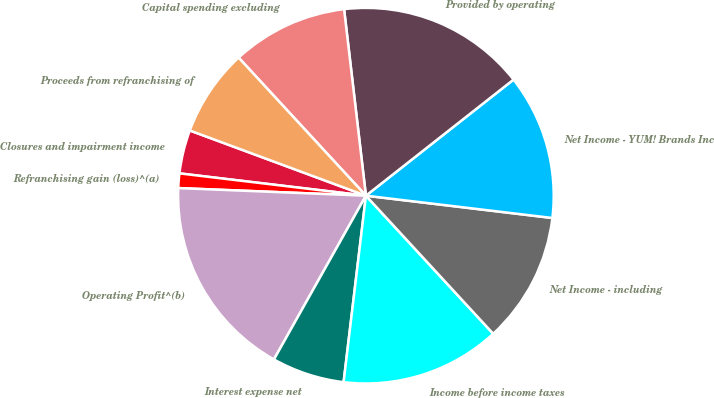Convert chart to OTSL. <chart><loc_0><loc_0><loc_500><loc_500><pie_chart><fcel>Closures and impairment income<fcel>Refranchising gain (loss)^(a)<fcel>Operating Profit^(b)<fcel>Interest expense net<fcel>Income before income taxes<fcel>Net Income - including<fcel>Net Income - YUM! Brands Inc<fcel>Provided by operating<fcel>Capital spending excluding<fcel>Proceeds from refranchising of<nl><fcel>3.75%<fcel>1.25%<fcel>17.5%<fcel>6.25%<fcel>13.75%<fcel>11.25%<fcel>12.5%<fcel>16.25%<fcel>10.0%<fcel>7.5%<nl></chart> 